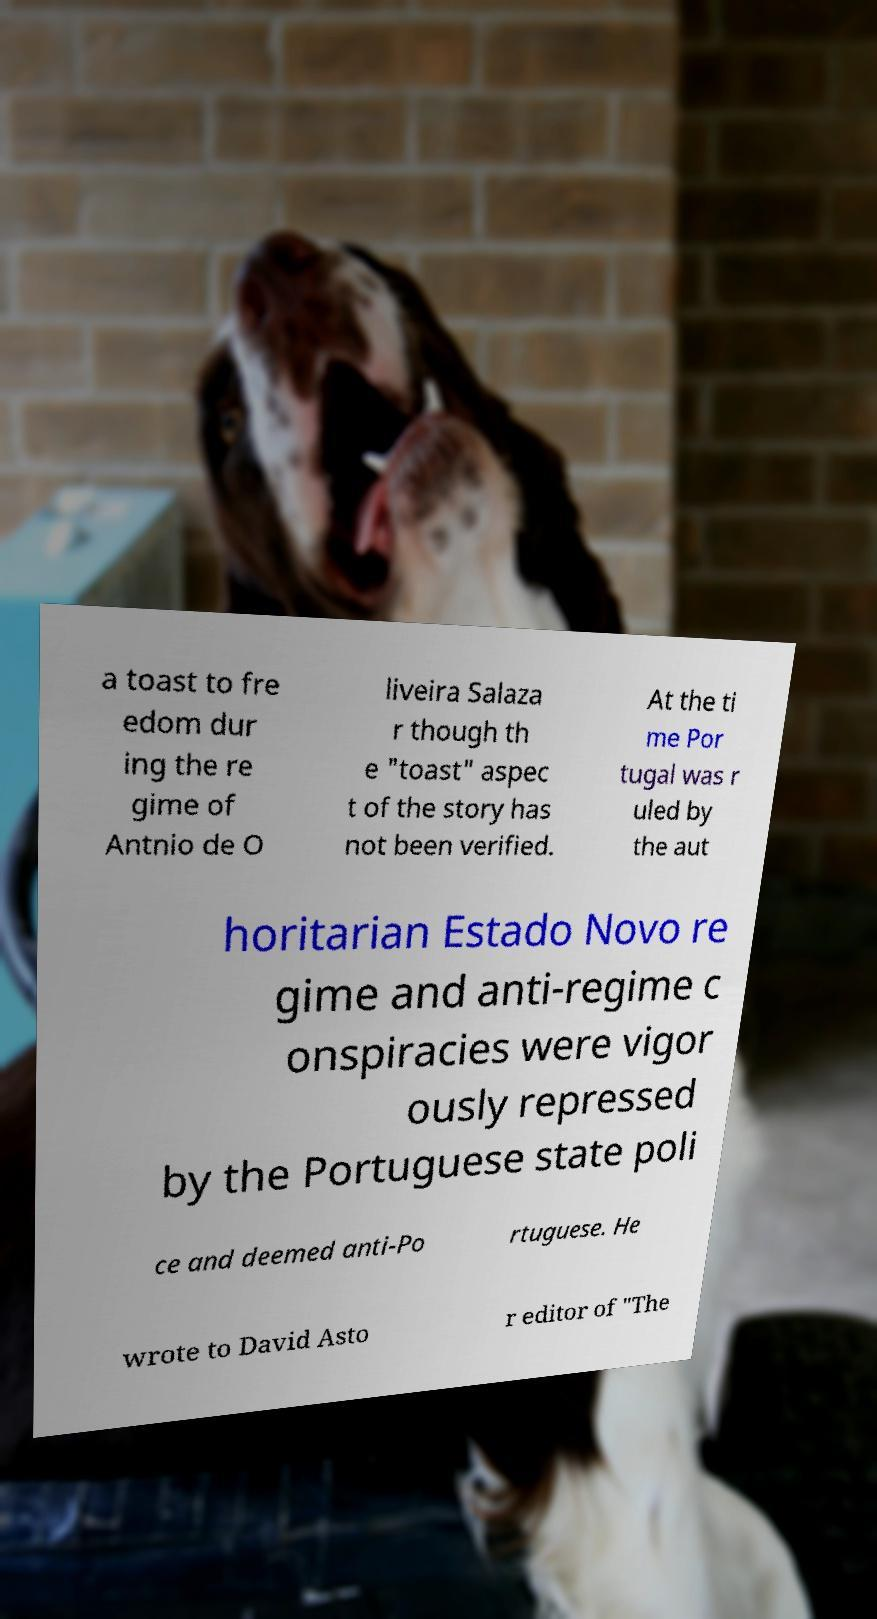Can you read and provide the text displayed in the image?This photo seems to have some interesting text. Can you extract and type it out for me? a toast to fre edom dur ing the re gime of Antnio de O liveira Salaza r though th e "toast" aspec t of the story has not been verified. At the ti me Por tugal was r uled by the aut horitarian Estado Novo re gime and anti-regime c onspiracies were vigor ously repressed by the Portuguese state poli ce and deemed anti-Po rtuguese. He wrote to David Asto r editor of "The 